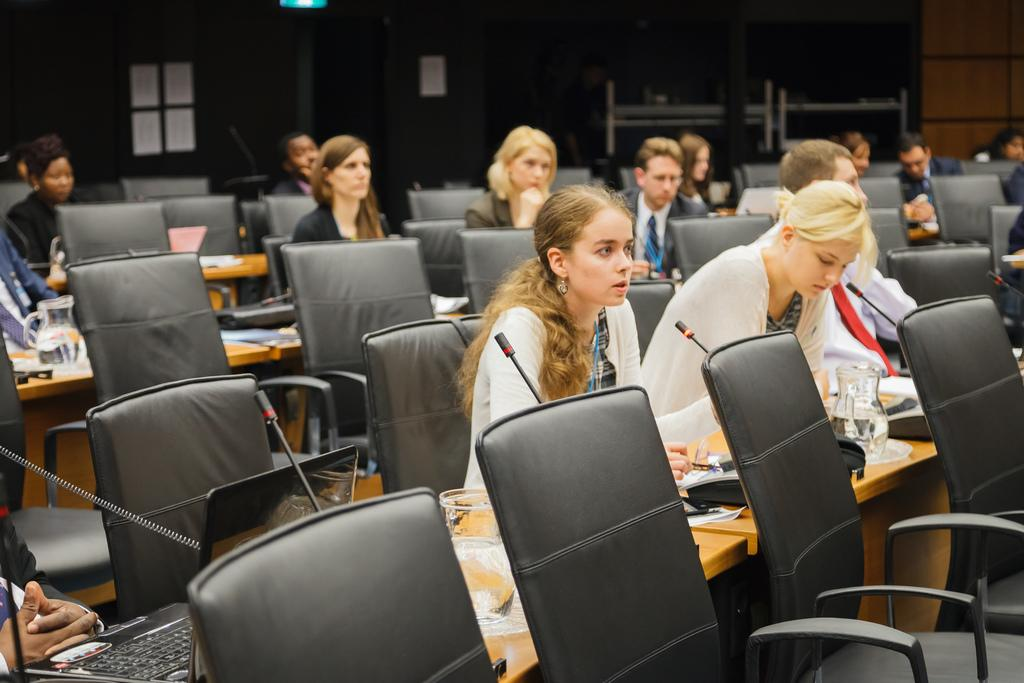How many people are in the image? There are people in the image, but the exact number is not specified. What are the people doing in the image? The people are sitting on chairs in the image. What is on the table in the image? There is a jug, a microphone (mike), and laptops on the table in the image. What type of silk fabric is draped over the laptops in the image? There is no silk fabric present in the image; the laptops are not covered by any fabric. 